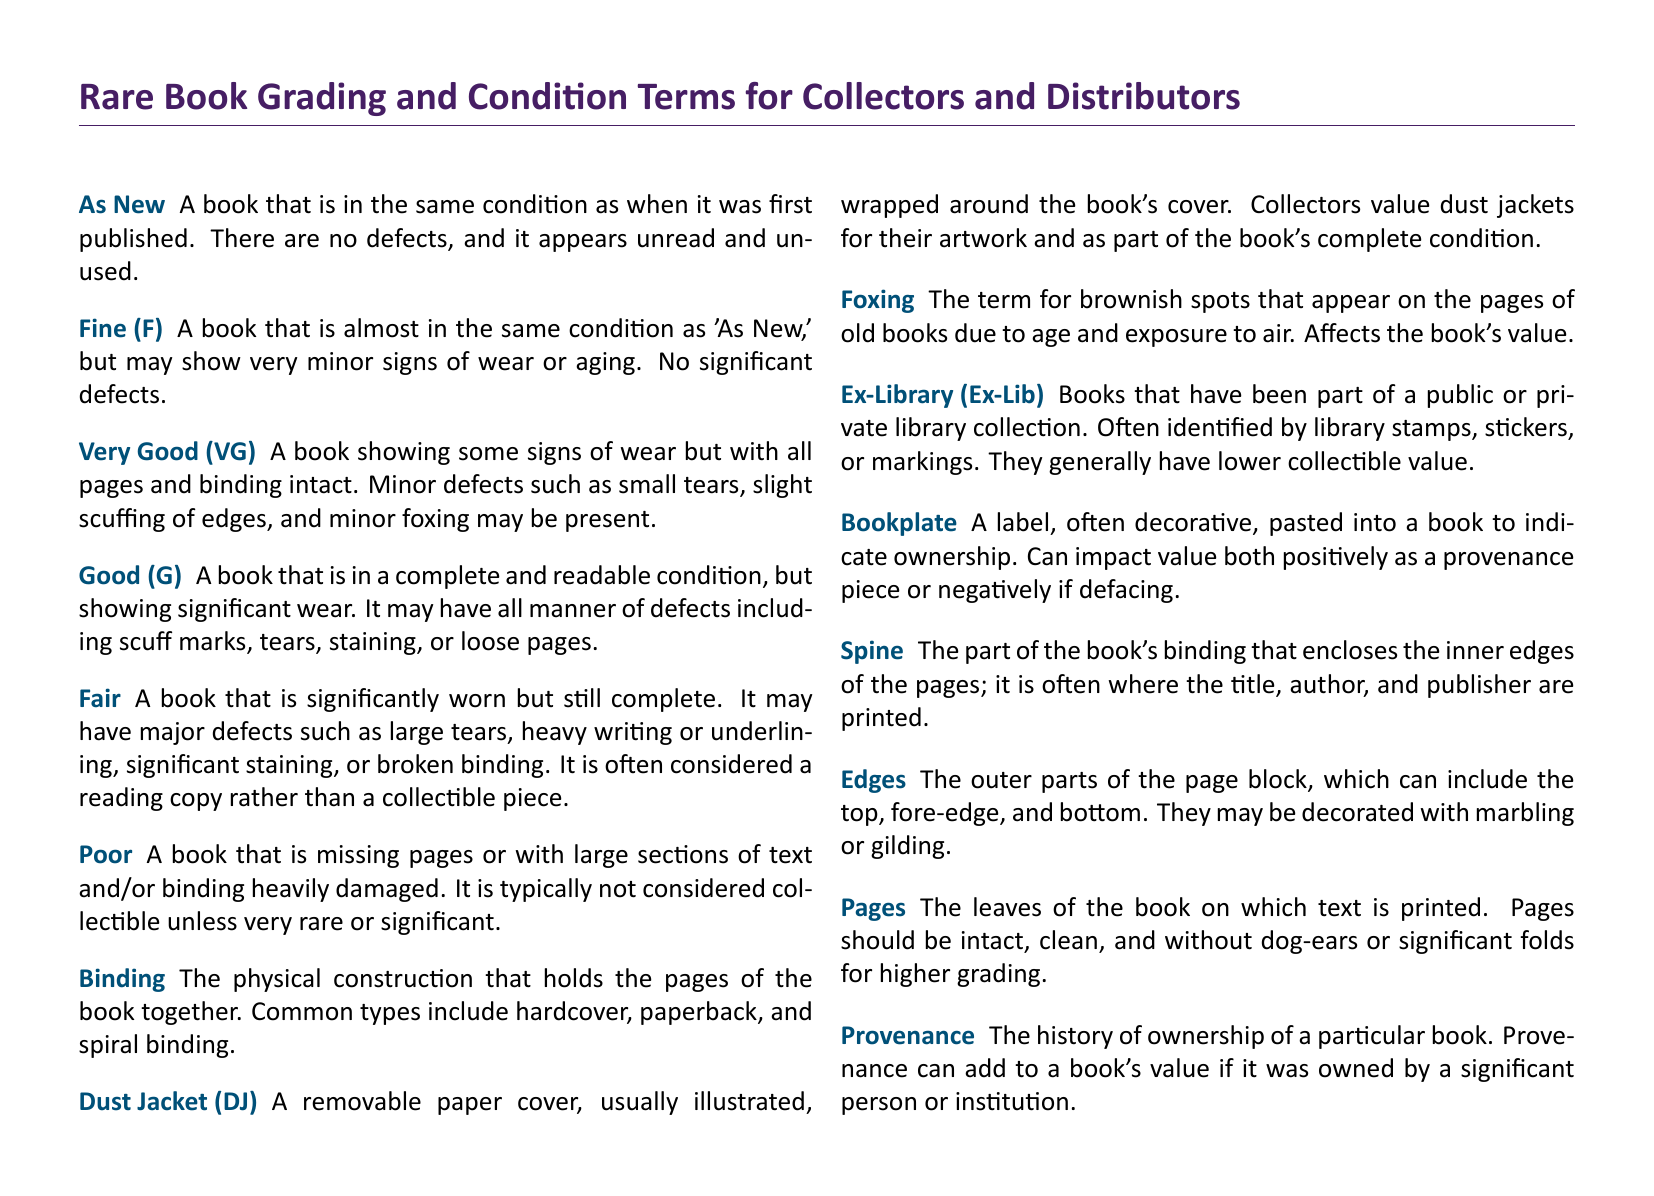What does "As New" refer to? The term "As New" describes a book that is in the same condition as when it was first published, indicating there are no defects.
Answer: A book in perfect condition What is a "Dust Jacket"? A "Dust Jacket" is a removable paper cover, usually illustrated, wrapped around the book's cover and valued for its artwork.
Answer: Removable paper cover What condition is indicated by "Good (G)"? "Good (G)" signifies a book that is complete and readable but shows significant wear with possible defects like scuff marks or tears.
Answer: Complete and readable condition What does "Foxing" refer to? "Foxing" describes brownish spots that appear on the pages of old books due to age, affecting the book's value.
Answer: Brownish spots What is the opposite of "Poor" regarding book condition? The term that indicates a better condition than "Poor" is "Fair," which still denotes significant wear but a more readable state.
Answer: Fair What is the significance of "Provenance"? "Provenance" refers to the history of ownership of a book, impacting its value positively or negatively based on past ownership.
Answer: History of ownership What type of binding includes hardcover and paperback? The term for the physical construction that holds the pages together is "Binding," which includes types like hardcover and paperback.
Answer: Binding What are "Edges" in the context of a book? "Edges" refer to the outer parts of the page block, which can include decorative features like marbling or gilding.
Answer: Outer parts of the page block What does "Ex-Library" mean? "Ex-Library" denotes books that have been part of a library collection and are often marked with stamps or stickers.
Answer: Library collection books What are "Pages" in a book? "Pages" are the leaves of the book on which text is printed; they should be intact and clean for higher grading.
Answer: Leaves of the book 